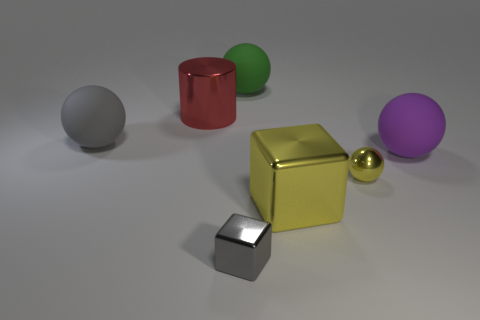Subtract all small balls. How many balls are left? 3 Add 2 gray metallic things. How many objects exist? 9 Subtract all yellow spheres. How many spheres are left? 3 Subtract all cylinders. How many objects are left? 6 Subtract 3 balls. How many balls are left? 1 Subtract all big gray rubber balls. Subtract all large yellow rubber cylinders. How many objects are left? 6 Add 6 purple balls. How many purple balls are left? 7 Add 6 small cyan rubber cylinders. How many small cyan rubber cylinders exist? 6 Subtract 0 purple cubes. How many objects are left? 7 Subtract all blue cylinders. Subtract all blue cubes. How many cylinders are left? 1 